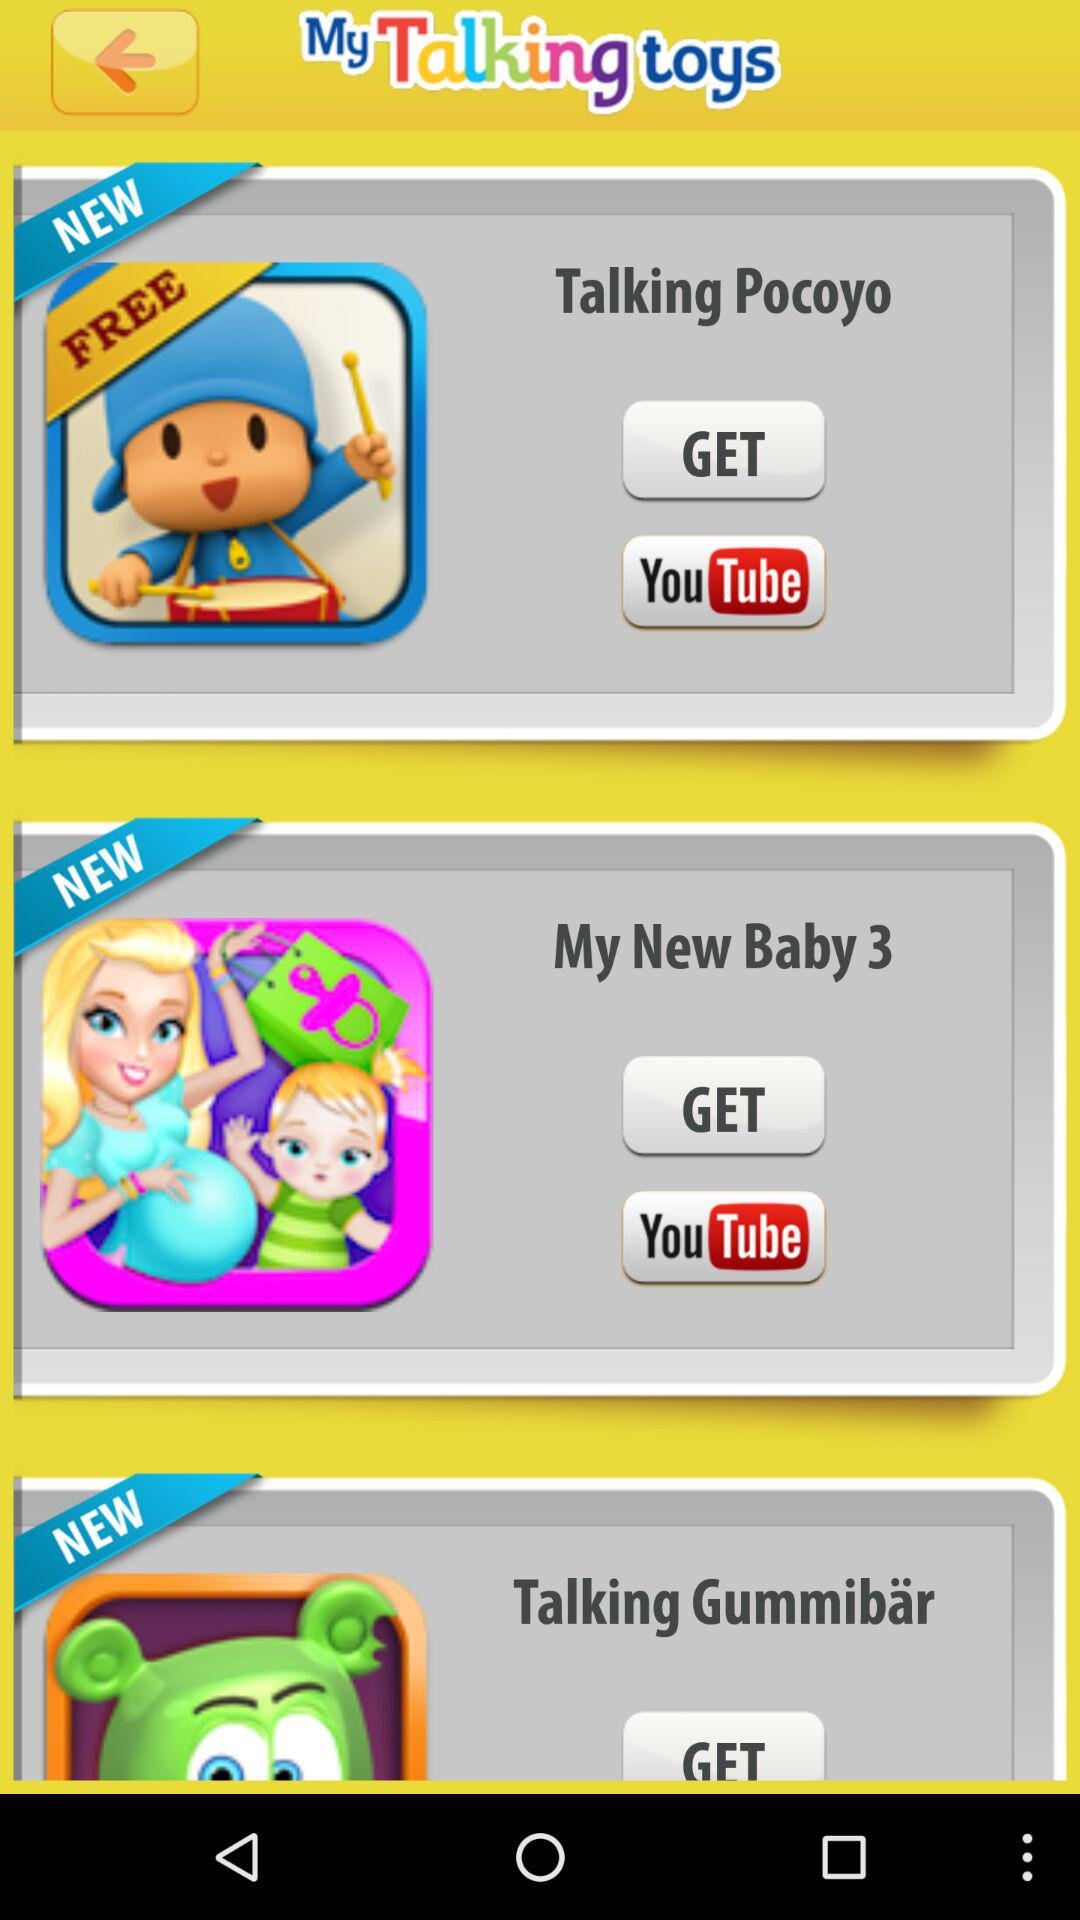What is the application name? The application name is "My Talking toys". 